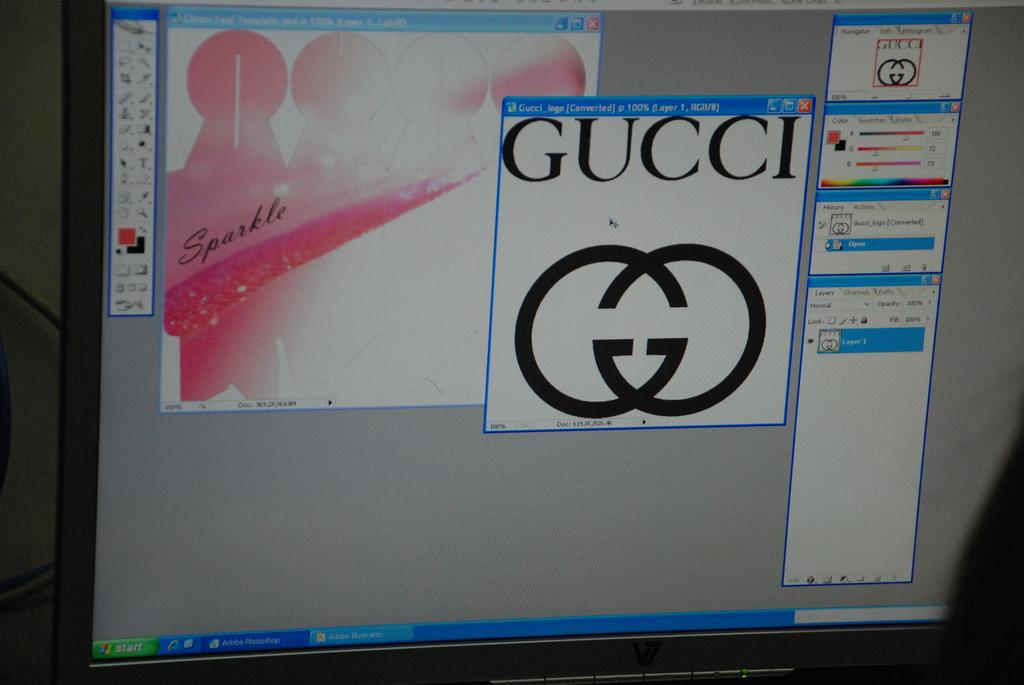<image>
Offer a succinct explanation of the picture presented. A gucci logo being displayed on a computer monitor 